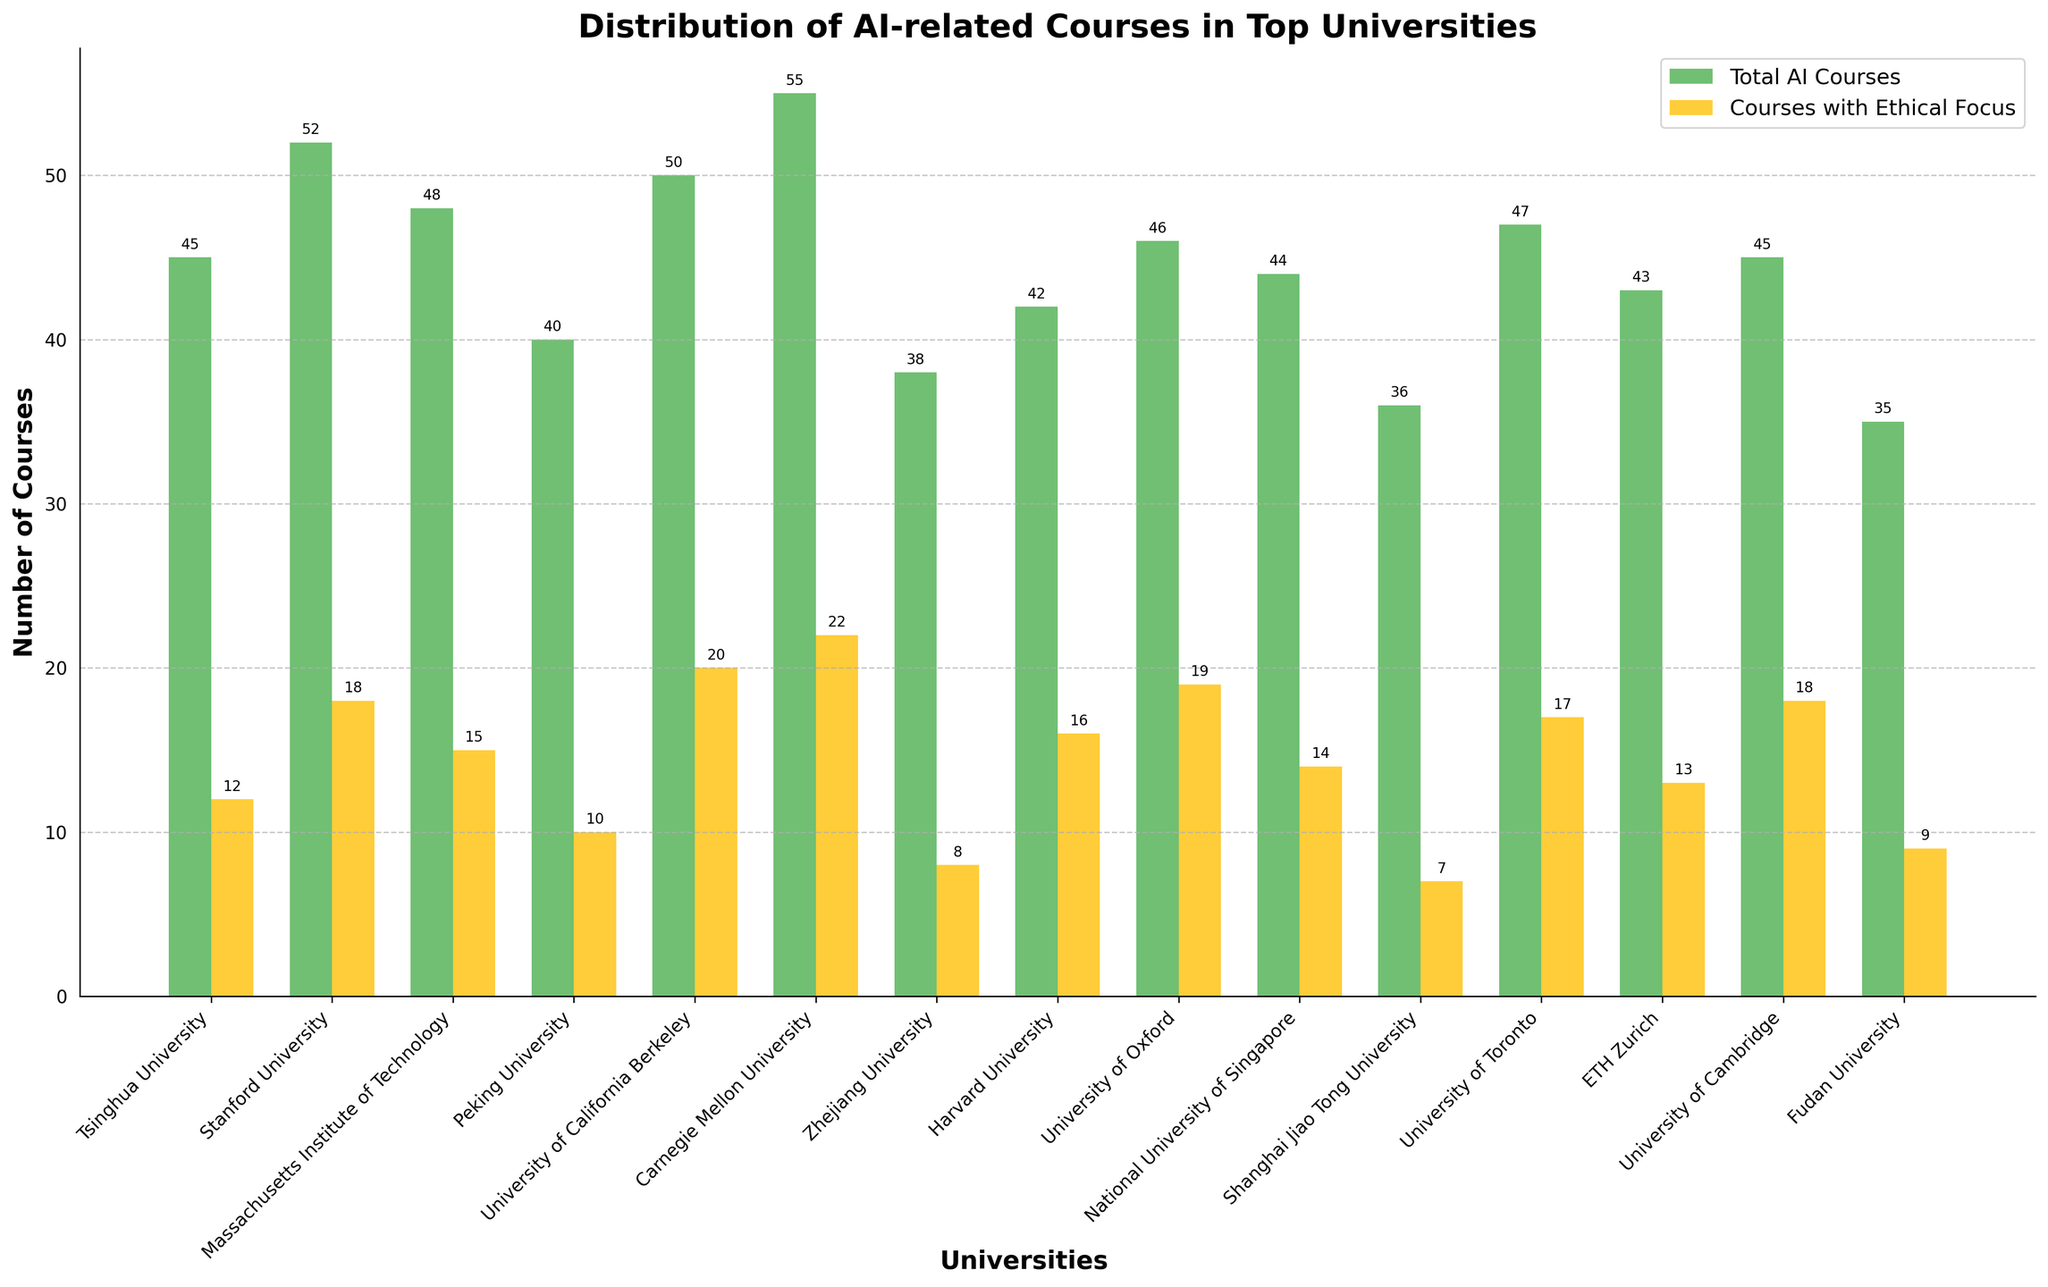Which university offers the most total AI-related courses? By looking at the bar chart, the tallest bar in the 'Total AI Courses' category is for Carnegie Mellon University.
Answer: Carnegie Mellon University Which university offers the fewest courses with an ethical focus? The shortest bar in the 'Courses with Ethical Focus' category corresponds to Shanghai Jiao Tong University.
Answer: Shanghai Jiao Tong University How many total AI courses are offered by Peking University and Harvard University combined? Add the total AI courses for Peking University (40) and Harvard University (42). 40 + 42 equals 82.
Answer: 82 Which university has a higher proportion of AI courses focused on ethics, University of Oxford or Massachusetts Institute of Technology? The University of Oxford has 19 ethical courses out of 46 total (19/46) and MIT has 15 ethical courses out of 48 total (15/48). Calculate these proportions: University of Oxford (approximately 0.41) and MIT (approximately 0.31).
Answer: University of Oxford Which color bars indicate the courses with an ethical focus? The bars representing 'Courses with Ethical Focus' are in yellow, as indicated in the legend.
Answer: Yellow Among the listed universities, which has more courses with an ethical focus: Stanford University or Harvard University? Count the number of courses with an ethical focus for Stanford University (18) and for Harvard University (16) and compare. 18 is greater than 16.
Answer: Stanford University Which university has an equal number of total AI courses as University of Cambridge but more courses with an ethical focus? University of Cambridge has 45 total AI courses and 18 ethical courses. Tsinghua University also has 45 total courses but fewer ethical courses (12), hence no university has both equal total AI courses and more ethical courses than University of Cambridge.
Answer: None How many more AI courses with ethical focus does Carnegie Mellon University have compared to Shanghai Jiao Tong University? Subtract the number of ethical courses in Shanghai Jiao Tong University (7) from those in Carnegie Mellon University (22). 22 - 7 equals 15.
Answer: 15 What is the visual difference between the bars representing total AI courses and ethical AI courses for ETH Zurich? The bar representing total AI courses for ETH Zurich is taller than the bar for ethical AI courses, with the total courses bar being noticeably higher.
Answer: Total AI courses bar is taller What is the total number of AI-related courses offered by the top three universities with the highest number of such courses? Carnegie Mellon University (55), Stanford University (52), and University of California Berkeley (50) offer the most total AI courses. Sum these values: 55 + 52 + 50 equals 157.
Answer: 157 